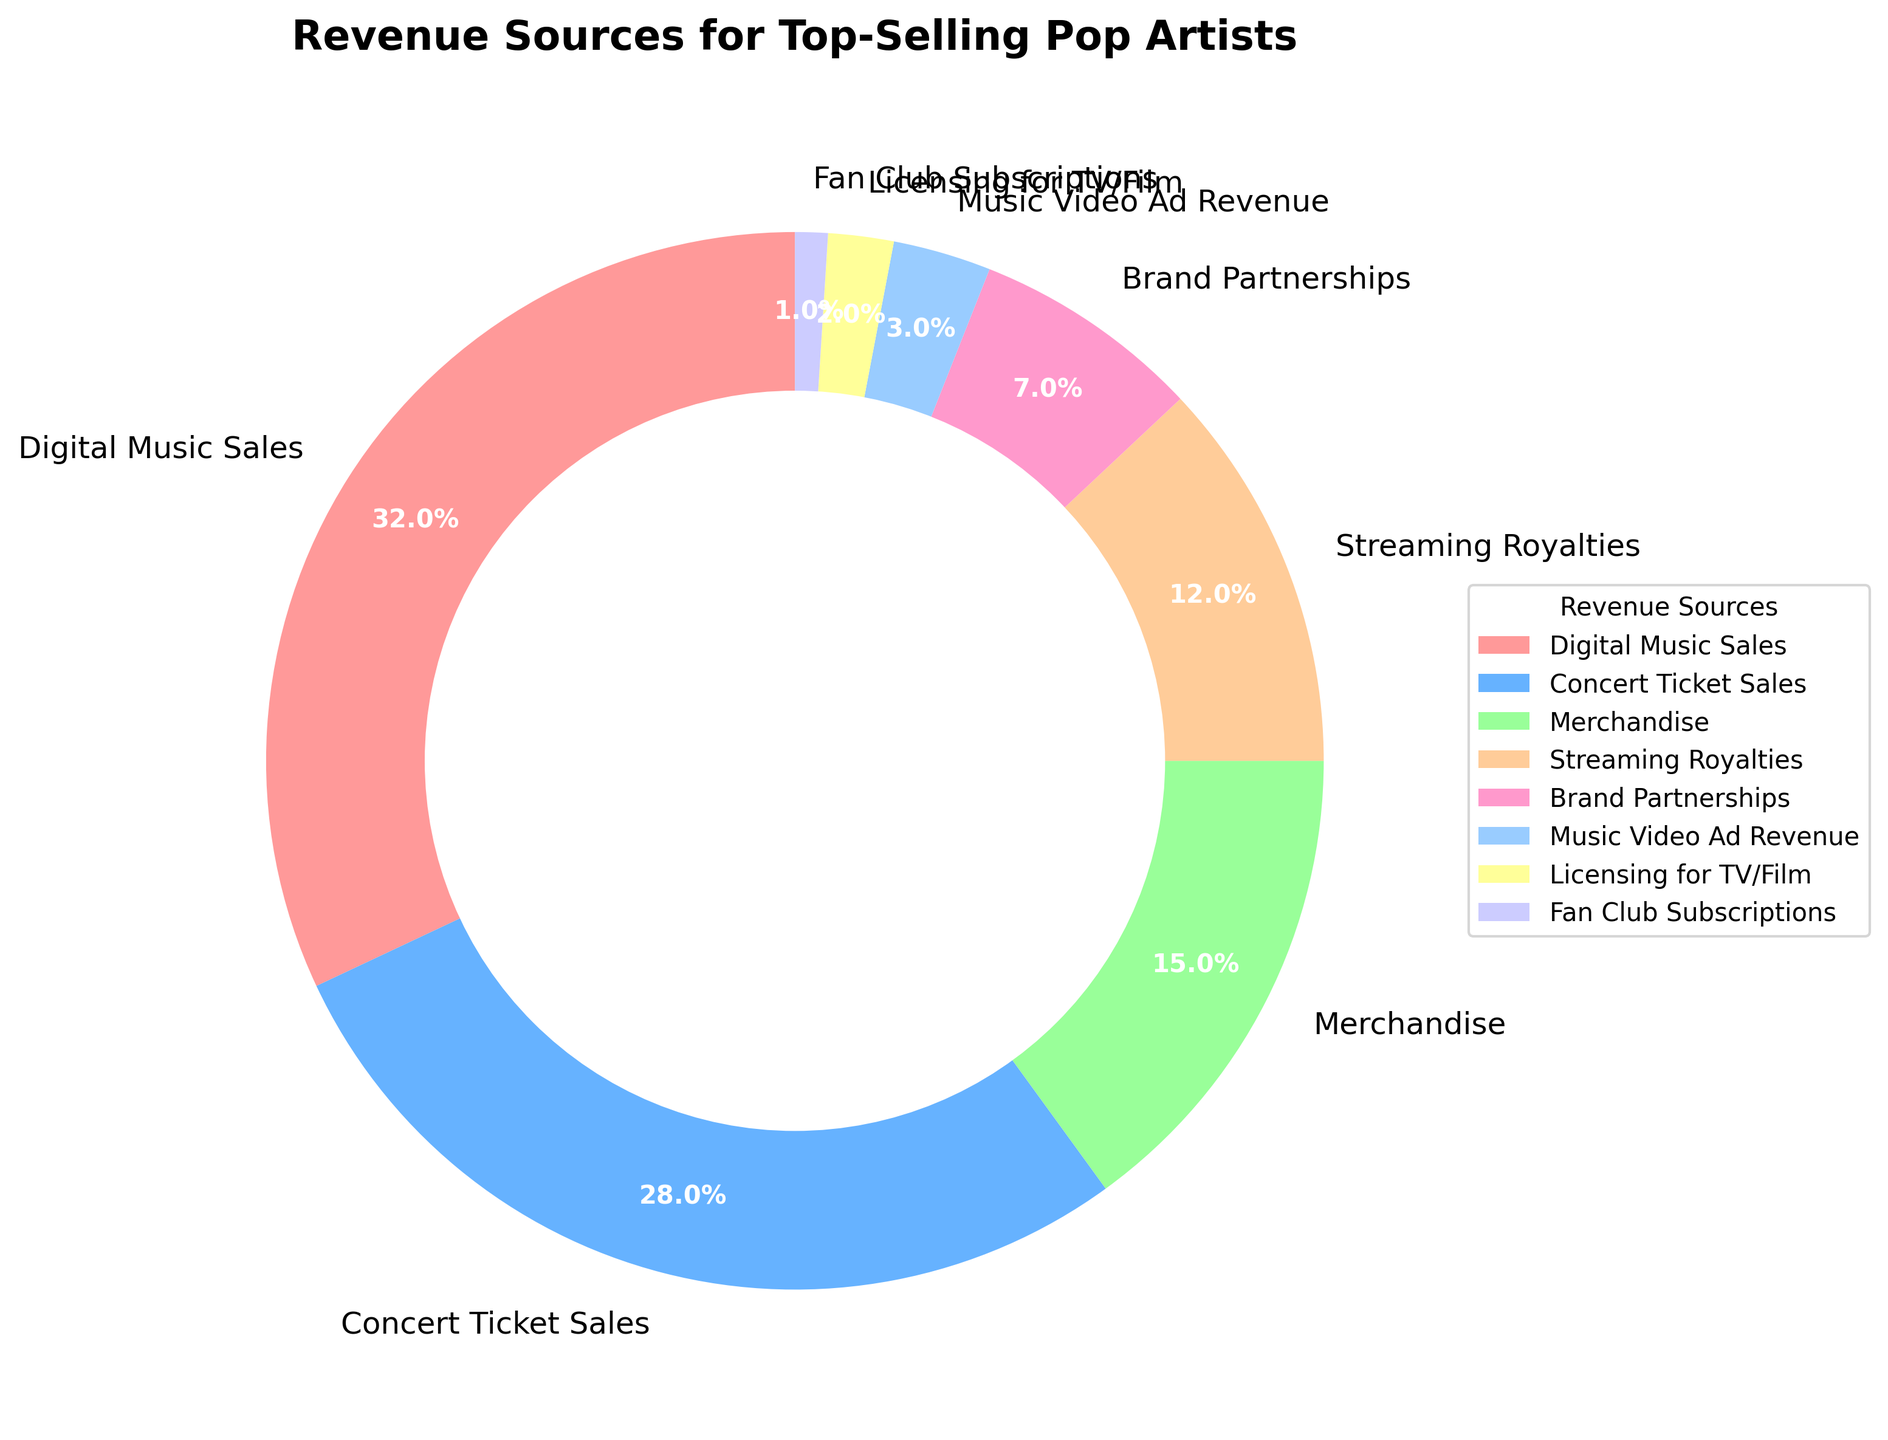Which revenue source contributes the most to the total revenue? The largest segment in the pie chart belongs to Digital Music Sales with a percentage of 32%.
Answer: Digital Music Sales Which revenue source contributes the least to the total revenue? The smallest segment in the pie chart belongs to Fan Club Subscriptions with a percentage of 1%.
Answer: Fan Club Subscriptions Is the percentage of Concert Ticket Sales greater or less than the percentage of Digital Music Sales? Concert Ticket Sales contribute 28%, which is less than the 32% contributed by Digital Music Sales.
Answer: Less What is the sum of the percentages for Merchandise and Streaming Royalties? Merchandise contributes 15% and Streaming Royalties contribute 12%. Summing these two gives 15% + 12% = 27%.
Answer: 27% Is the percentage of Streaming Royalties closer to the percentage of Brand Partnerships or Digital Music Sales? Streaming Royalties have a percentage of 12%. Brand Partnerships have 7%, and Digital Music Sales have 32%. The difference between Streaming Royalties and Brand Partnerships is 12% - 7% = 5%, whereas the difference between Streaming Royalties and Digital Music Sales is 32% - 12% = 20%. Therefore, Streaming Royalties is closer to Brand Partnerships.
Answer: Brand Partnerships What is the combined percentage of less common revenue sources (with contributions less than 10%)? The less common revenue sources are Brand Partnerships (7%), Music Video Ad Revenue (3%), Licensing for TV/Film (2%), and Fan Club Subscriptions (1%). Adding these gives 7% + 3% + 2% + 1% = 13%.
Answer: 13% Which revenue sources are represented by pink and yellow segments, respectively? The pink segment represents Digital Music Sales with 32%, and the yellow segment represents Merchandise with 15%.
Answer: Digital Music Sales, Merchandise 